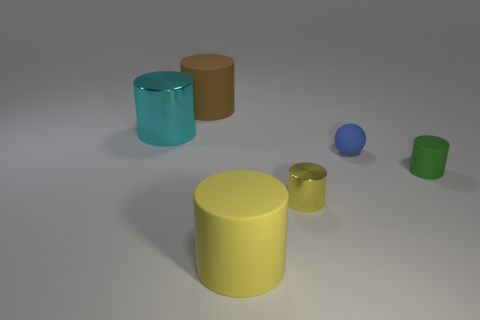What is the small blue object made of?
Keep it short and to the point. Rubber. Are there the same number of big brown rubber things on the left side of the large cyan cylinder and brown rubber cylinders?
Keep it short and to the point. No. How many brown things are the same shape as the large cyan object?
Provide a succinct answer. 1. Do the big cyan metallic thing and the brown rubber thing have the same shape?
Give a very brief answer. Yes. How many things are either big matte things that are in front of the small blue matte sphere or small yellow metal things?
Your answer should be very brief. 2. What is the shape of the shiny thing on the right side of the cylinder behind the metallic cylinder behind the small green object?
Your answer should be compact. Cylinder. The large yellow object that is made of the same material as the tiny green cylinder is what shape?
Offer a terse response. Cylinder. What is the size of the matte ball?
Your response must be concise. Small. Do the blue sphere and the cyan cylinder have the same size?
Provide a succinct answer. No. What number of objects are either big cylinders that are behind the tiny green object or large rubber things in front of the small yellow object?
Provide a short and direct response. 3. 